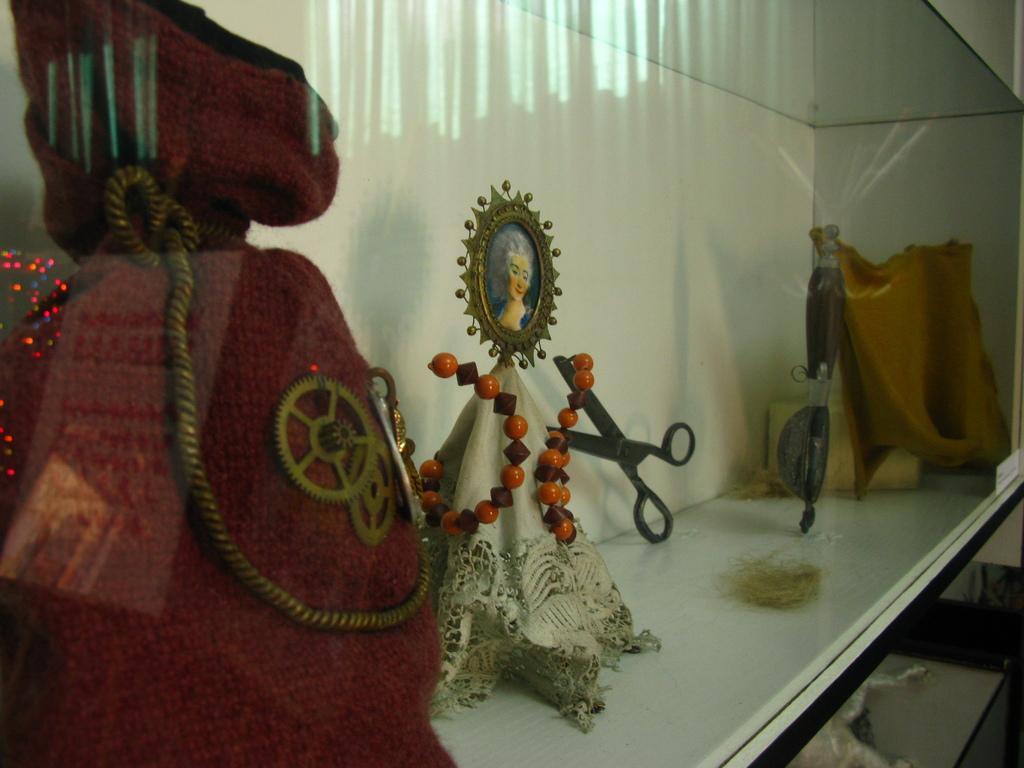Please provide a concise description of this image. In the foreground of this image, there is a red bag, scissor and few show case objects inside the glass. 